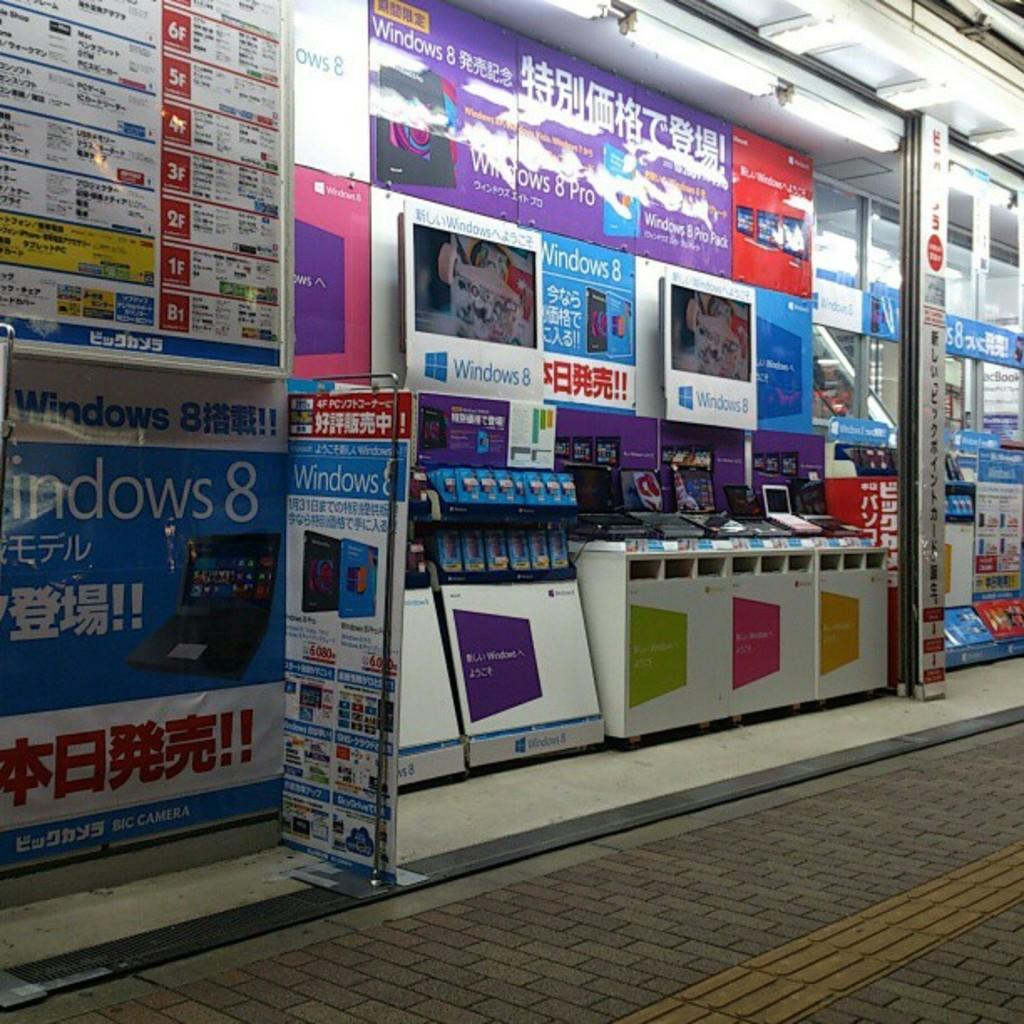Provide a one-sentence caption for the provided image. Booths for the Windows 8 computer are against the wall. 